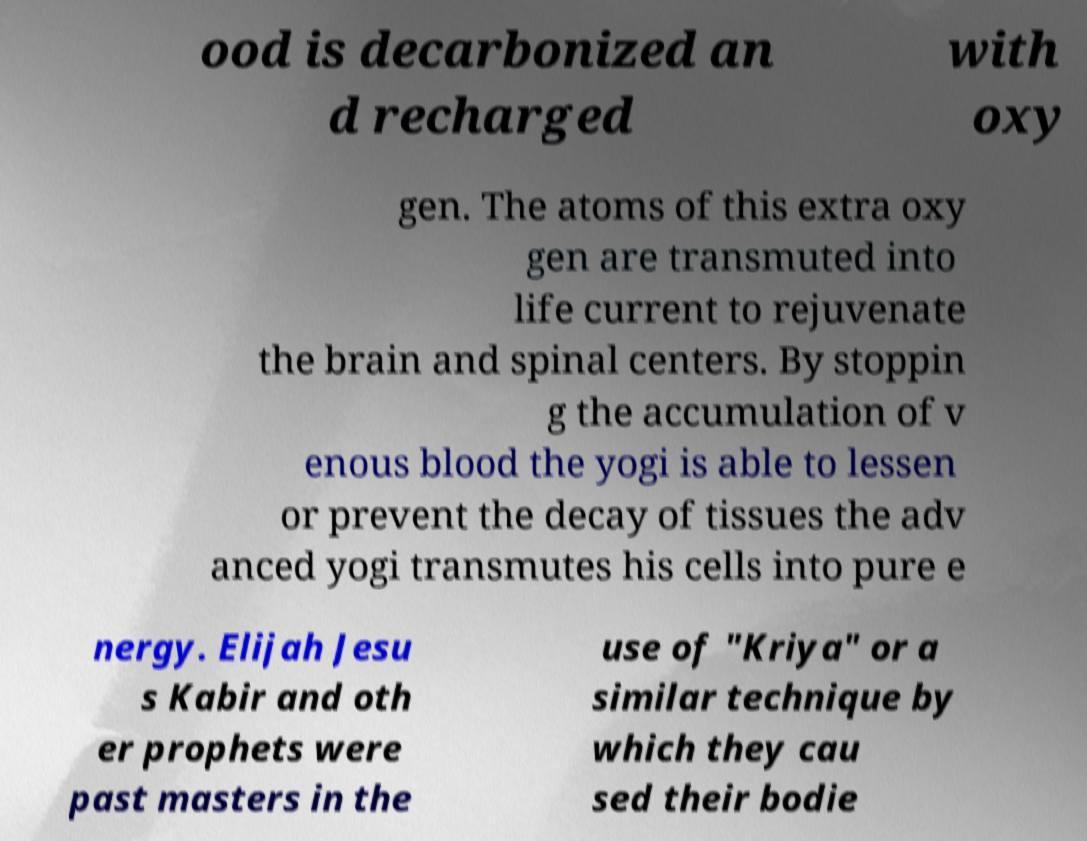Could you extract and type out the text from this image? ood is decarbonized an d recharged with oxy gen. The atoms of this extra oxy gen are transmuted into life current to rejuvenate the brain and spinal centers. By stoppin g the accumulation of v enous blood the yogi is able to lessen or prevent the decay of tissues the adv anced yogi transmutes his cells into pure e nergy. Elijah Jesu s Kabir and oth er prophets were past masters in the use of "Kriya" or a similar technique by which they cau sed their bodie 